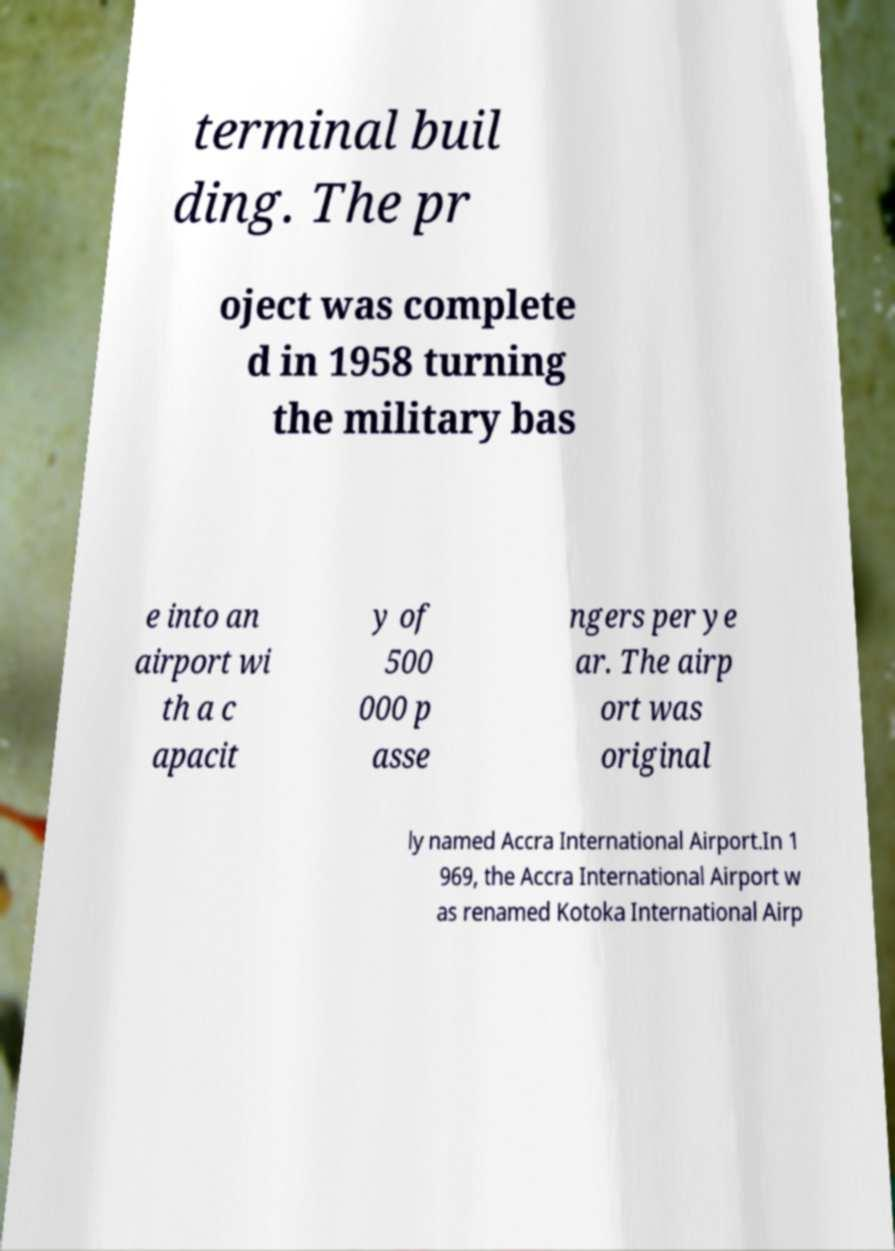Can you read and provide the text displayed in the image?This photo seems to have some interesting text. Can you extract and type it out for me? terminal buil ding. The pr oject was complete d in 1958 turning the military bas e into an airport wi th a c apacit y of 500 000 p asse ngers per ye ar. The airp ort was original ly named Accra International Airport.In 1 969, the Accra International Airport w as renamed Kotoka International Airp 